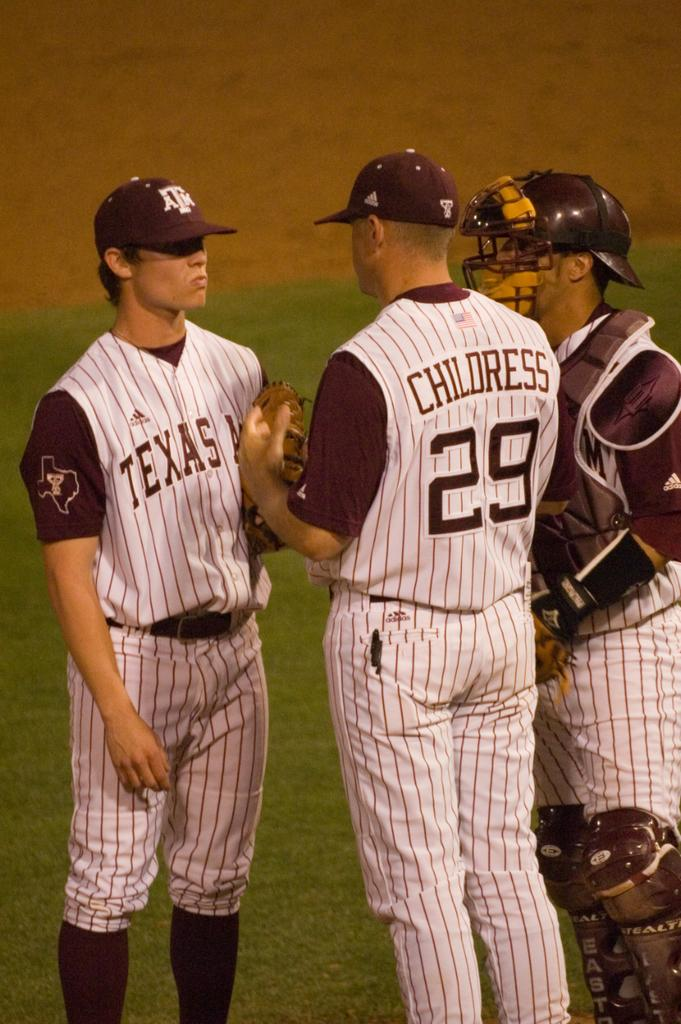<image>
Offer a succinct explanation of the picture presented. A baseball player named Childress talks to two other players on the Texas team. 